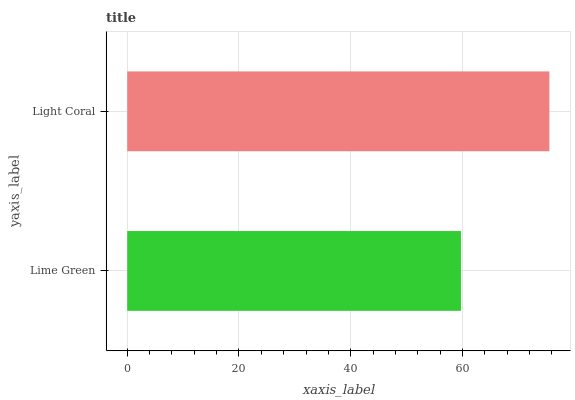Is Lime Green the minimum?
Answer yes or no. Yes. Is Light Coral the maximum?
Answer yes or no. Yes. Is Light Coral the minimum?
Answer yes or no. No. Is Light Coral greater than Lime Green?
Answer yes or no. Yes. Is Lime Green less than Light Coral?
Answer yes or no. Yes. Is Lime Green greater than Light Coral?
Answer yes or no. No. Is Light Coral less than Lime Green?
Answer yes or no. No. Is Light Coral the high median?
Answer yes or no. Yes. Is Lime Green the low median?
Answer yes or no. Yes. Is Lime Green the high median?
Answer yes or no. No. Is Light Coral the low median?
Answer yes or no. No. 